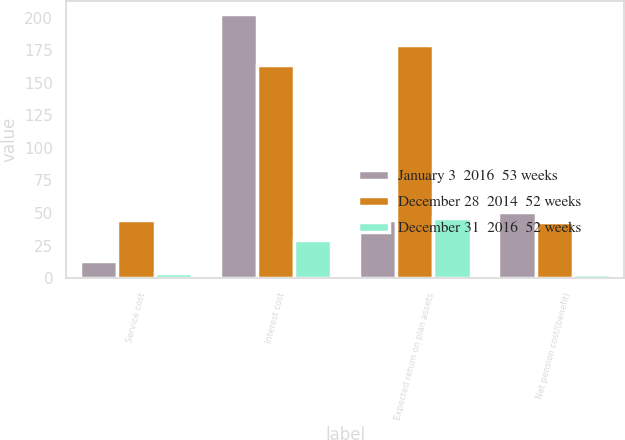Convert chart. <chart><loc_0><loc_0><loc_500><loc_500><stacked_bar_chart><ecel><fcel>Service cost<fcel>Interest cost<fcel>Expected return on plan assets<fcel>Net pension cost/(benefit)<nl><fcel>January 3  2016  53 weeks<fcel>13<fcel>203<fcel>45<fcel>51<nl><fcel>December 28  2014  52 weeks<fcel>45<fcel>164<fcel>179<fcel>43<nl><fcel>December 31  2016  52 weeks<fcel>4<fcel>29<fcel>46<fcel>3<nl></chart> 